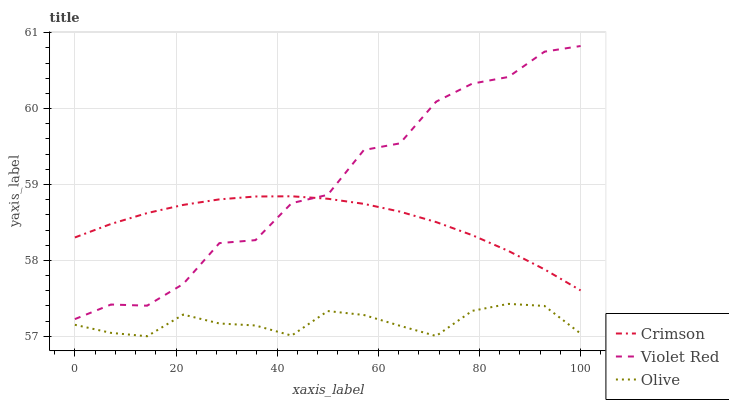Does Olive have the minimum area under the curve?
Answer yes or no. Yes. Does Violet Red have the maximum area under the curve?
Answer yes or no. Yes. Does Violet Red have the minimum area under the curve?
Answer yes or no. No. Does Olive have the maximum area under the curve?
Answer yes or no. No. Is Crimson the smoothest?
Answer yes or no. Yes. Is Violet Red the roughest?
Answer yes or no. Yes. Is Olive the smoothest?
Answer yes or no. No. Is Olive the roughest?
Answer yes or no. No. Does Olive have the lowest value?
Answer yes or no. Yes. Does Violet Red have the lowest value?
Answer yes or no. No. Does Violet Red have the highest value?
Answer yes or no. Yes. Does Olive have the highest value?
Answer yes or no. No. Is Olive less than Violet Red?
Answer yes or no. Yes. Is Violet Red greater than Olive?
Answer yes or no. Yes. Does Crimson intersect Violet Red?
Answer yes or no. Yes. Is Crimson less than Violet Red?
Answer yes or no. No. Is Crimson greater than Violet Red?
Answer yes or no. No. Does Olive intersect Violet Red?
Answer yes or no. No. 